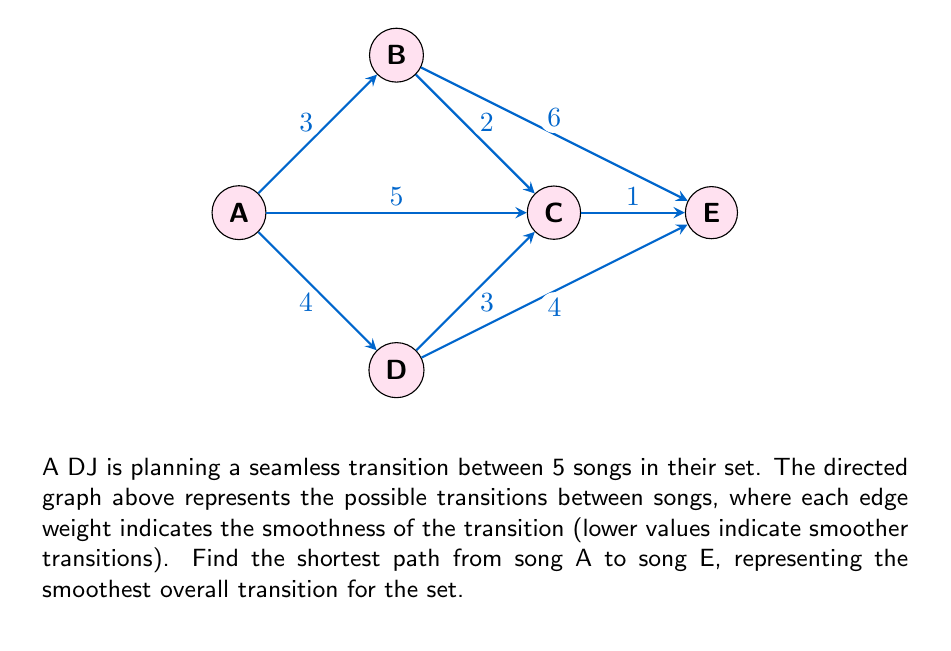Teach me how to tackle this problem. To find the shortest path from A to E, we can use Dijkstra's algorithm. This algorithm finds the shortest path from a starting node to all other nodes in a weighted directed graph.

Steps:
1. Initialize distances: A(0), B(∞), C(∞), D(∞), E(∞)
2. Set A as the current node
3. Update distances to neighboring nodes:
   B: min(∞, 0+3) = 3
   C: min(∞, 0+5) = 5
   D: min(∞, 0+4) = 4
4. Mark A as visited, set B as current (smallest unvisited distance)
5. Update distances from B:
   C: min(5, 3+2) = 5
   E: min(∞, 3+6) = 9
6. Mark B as visited, set D as current
7. Update distances from D:
   C: min(5, 4+3) = 5
   E: min(9, 4+4) = 8
8. Mark D as visited, set C as current
9. Update distance to E:
   E: min(8, 5+1) = 6
10. Mark C as visited, set E as current (all nodes visited)

The shortest path is A → C → E with a total weight of 6.
Answer: The shortest path from A to E is A → C → E, with a total weight of 6. 